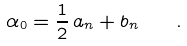Convert formula to latex. <formula><loc_0><loc_0><loc_500><loc_500>\alpha _ { 0 } = \frac { 1 } { 2 } \, a _ { n } + b _ { n } \quad .</formula> 